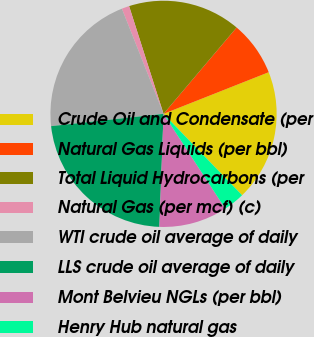<chart> <loc_0><loc_0><loc_500><loc_500><pie_chart><fcel>Crude Oil and Condensate (per<fcel>Natural Gas Liquids (per bbl)<fcel>Total Liquid Hydrocarbons (per<fcel>Natural Gas (per mcf) (c)<fcel>WTI crude oil average of daily<fcel>LLS crude oil average of daily<fcel>Mont Belvieu NGLs (per bbl)<fcel>Henry Hub natural gas<nl><fcel>18.78%<fcel>7.82%<fcel>16.1%<fcel>1.08%<fcel>20.73%<fcel>22.68%<fcel>9.77%<fcel>3.03%<nl></chart> 